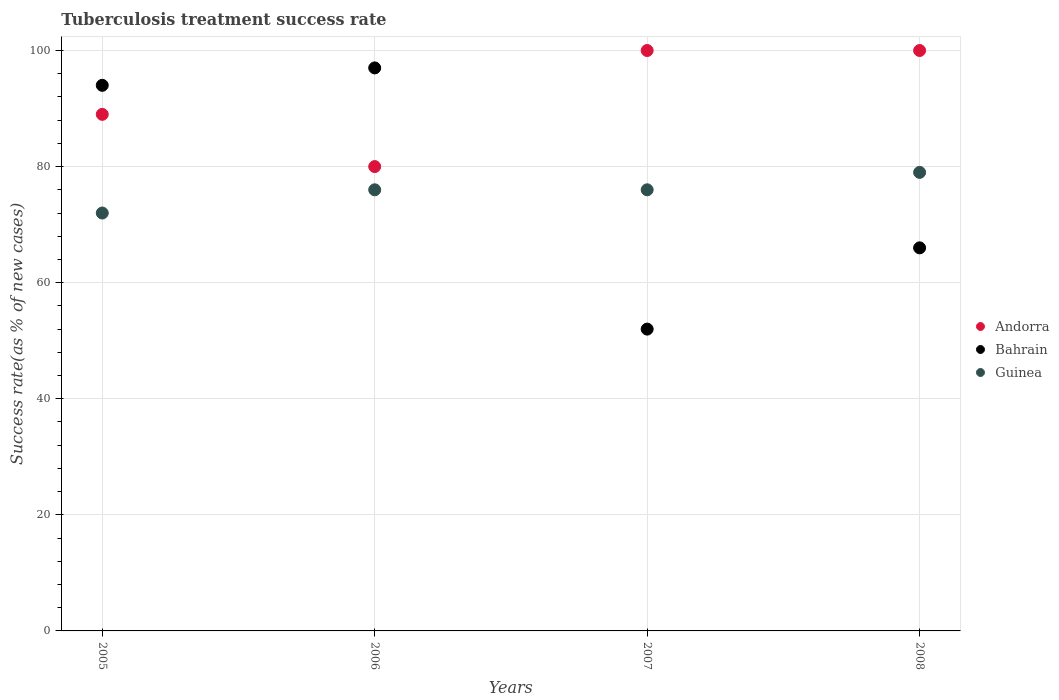How many different coloured dotlines are there?
Your response must be concise. 3. Across all years, what is the maximum tuberculosis treatment success rate in Guinea?
Provide a short and direct response. 79. In which year was the tuberculosis treatment success rate in Andorra minimum?
Make the answer very short. 2006. What is the total tuberculosis treatment success rate in Bahrain in the graph?
Give a very brief answer. 309. What is the difference between the tuberculosis treatment success rate in Andorra in 2006 and that in 2007?
Keep it short and to the point. -20. What is the difference between the tuberculosis treatment success rate in Andorra in 2007 and the tuberculosis treatment success rate in Bahrain in 2008?
Your answer should be very brief. 34. What is the average tuberculosis treatment success rate in Bahrain per year?
Offer a terse response. 77.25. Is the tuberculosis treatment success rate in Bahrain in 2005 less than that in 2008?
Your answer should be compact. No. What is the difference between the highest and the lowest tuberculosis treatment success rate in Guinea?
Make the answer very short. 7. In how many years, is the tuberculosis treatment success rate in Bahrain greater than the average tuberculosis treatment success rate in Bahrain taken over all years?
Your answer should be very brief. 2. Is the sum of the tuberculosis treatment success rate in Guinea in 2005 and 2007 greater than the maximum tuberculosis treatment success rate in Bahrain across all years?
Provide a short and direct response. Yes. Is it the case that in every year, the sum of the tuberculosis treatment success rate in Andorra and tuberculosis treatment success rate in Bahrain  is greater than the tuberculosis treatment success rate in Guinea?
Offer a terse response. Yes. Does the tuberculosis treatment success rate in Andorra monotonically increase over the years?
Make the answer very short. No. Is the tuberculosis treatment success rate in Andorra strictly greater than the tuberculosis treatment success rate in Bahrain over the years?
Your response must be concise. No. How many dotlines are there?
Ensure brevity in your answer.  3. What is the difference between two consecutive major ticks on the Y-axis?
Provide a short and direct response. 20. Does the graph contain any zero values?
Ensure brevity in your answer.  No. Where does the legend appear in the graph?
Provide a short and direct response. Center right. How many legend labels are there?
Give a very brief answer. 3. How are the legend labels stacked?
Your answer should be very brief. Vertical. What is the title of the graph?
Make the answer very short. Tuberculosis treatment success rate. What is the label or title of the Y-axis?
Your answer should be very brief. Success rate(as % of new cases). What is the Success rate(as % of new cases) of Andorra in 2005?
Your answer should be very brief. 89. What is the Success rate(as % of new cases) in Bahrain in 2005?
Provide a succinct answer. 94. What is the Success rate(as % of new cases) in Guinea in 2005?
Your answer should be compact. 72. What is the Success rate(as % of new cases) in Bahrain in 2006?
Your answer should be compact. 97. What is the Success rate(as % of new cases) of Guinea in 2006?
Your response must be concise. 76. What is the Success rate(as % of new cases) of Andorra in 2007?
Your response must be concise. 100. What is the Success rate(as % of new cases) in Bahrain in 2007?
Give a very brief answer. 52. What is the Success rate(as % of new cases) of Bahrain in 2008?
Offer a terse response. 66. What is the Success rate(as % of new cases) of Guinea in 2008?
Offer a very short reply. 79. Across all years, what is the maximum Success rate(as % of new cases) of Bahrain?
Your answer should be compact. 97. Across all years, what is the maximum Success rate(as % of new cases) of Guinea?
Your answer should be compact. 79. Across all years, what is the minimum Success rate(as % of new cases) in Andorra?
Ensure brevity in your answer.  80. What is the total Success rate(as % of new cases) of Andorra in the graph?
Provide a succinct answer. 369. What is the total Success rate(as % of new cases) of Bahrain in the graph?
Provide a short and direct response. 309. What is the total Success rate(as % of new cases) in Guinea in the graph?
Your answer should be compact. 303. What is the difference between the Success rate(as % of new cases) of Andorra in 2005 and that in 2006?
Make the answer very short. 9. What is the difference between the Success rate(as % of new cases) in Guinea in 2005 and that in 2006?
Your answer should be compact. -4. What is the difference between the Success rate(as % of new cases) in Bahrain in 2005 and that in 2007?
Keep it short and to the point. 42. What is the difference between the Success rate(as % of new cases) in Andorra in 2005 and that in 2008?
Provide a succinct answer. -11. What is the difference between the Success rate(as % of new cases) in Bahrain in 2005 and that in 2008?
Your answer should be compact. 28. What is the difference between the Success rate(as % of new cases) of Guinea in 2006 and that in 2007?
Give a very brief answer. 0. What is the difference between the Success rate(as % of new cases) of Bahrain in 2007 and that in 2008?
Offer a terse response. -14. What is the difference between the Success rate(as % of new cases) of Guinea in 2007 and that in 2008?
Keep it short and to the point. -3. What is the difference between the Success rate(as % of new cases) of Andorra in 2005 and the Success rate(as % of new cases) of Bahrain in 2007?
Give a very brief answer. 37. What is the difference between the Success rate(as % of new cases) in Andorra in 2005 and the Success rate(as % of new cases) in Guinea in 2007?
Provide a short and direct response. 13. What is the difference between the Success rate(as % of new cases) in Andorra in 2005 and the Success rate(as % of new cases) in Bahrain in 2008?
Ensure brevity in your answer.  23. What is the difference between the Success rate(as % of new cases) of Andorra in 2006 and the Success rate(as % of new cases) of Guinea in 2007?
Provide a succinct answer. 4. What is the difference between the Success rate(as % of new cases) of Bahrain in 2006 and the Success rate(as % of new cases) of Guinea in 2007?
Offer a terse response. 21. What is the difference between the Success rate(as % of new cases) of Andorra in 2006 and the Success rate(as % of new cases) of Bahrain in 2008?
Offer a terse response. 14. What is the difference between the Success rate(as % of new cases) in Bahrain in 2006 and the Success rate(as % of new cases) in Guinea in 2008?
Offer a very short reply. 18. What is the difference between the Success rate(as % of new cases) of Andorra in 2007 and the Success rate(as % of new cases) of Bahrain in 2008?
Make the answer very short. 34. What is the difference between the Success rate(as % of new cases) of Andorra in 2007 and the Success rate(as % of new cases) of Guinea in 2008?
Keep it short and to the point. 21. What is the difference between the Success rate(as % of new cases) of Bahrain in 2007 and the Success rate(as % of new cases) of Guinea in 2008?
Provide a short and direct response. -27. What is the average Success rate(as % of new cases) of Andorra per year?
Your answer should be very brief. 92.25. What is the average Success rate(as % of new cases) in Bahrain per year?
Your answer should be compact. 77.25. What is the average Success rate(as % of new cases) in Guinea per year?
Offer a very short reply. 75.75. In the year 2005, what is the difference between the Success rate(as % of new cases) of Andorra and Success rate(as % of new cases) of Bahrain?
Offer a terse response. -5. In the year 2005, what is the difference between the Success rate(as % of new cases) in Andorra and Success rate(as % of new cases) in Guinea?
Your answer should be compact. 17. In the year 2006, what is the difference between the Success rate(as % of new cases) of Andorra and Success rate(as % of new cases) of Guinea?
Give a very brief answer. 4. In the year 2006, what is the difference between the Success rate(as % of new cases) of Bahrain and Success rate(as % of new cases) of Guinea?
Ensure brevity in your answer.  21. In the year 2007, what is the difference between the Success rate(as % of new cases) in Andorra and Success rate(as % of new cases) in Bahrain?
Keep it short and to the point. 48. In the year 2007, what is the difference between the Success rate(as % of new cases) of Andorra and Success rate(as % of new cases) of Guinea?
Offer a terse response. 24. In the year 2008, what is the difference between the Success rate(as % of new cases) in Andorra and Success rate(as % of new cases) in Guinea?
Your answer should be very brief. 21. In the year 2008, what is the difference between the Success rate(as % of new cases) of Bahrain and Success rate(as % of new cases) of Guinea?
Offer a very short reply. -13. What is the ratio of the Success rate(as % of new cases) of Andorra in 2005 to that in 2006?
Give a very brief answer. 1.11. What is the ratio of the Success rate(as % of new cases) of Bahrain in 2005 to that in 2006?
Your answer should be compact. 0.97. What is the ratio of the Success rate(as % of new cases) of Guinea in 2005 to that in 2006?
Your answer should be compact. 0.95. What is the ratio of the Success rate(as % of new cases) in Andorra in 2005 to that in 2007?
Your answer should be compact. 0.89. What is the ratio of the Success rate(as % of new cases) of Bahrain in 2005 to that in 2007?
Offer a terse response. 1.81. What is the ratio of the Success rate(as % of new cases) in Andorra in 2005 to that in 2008?
Offer a terse response. 0.89. What is the ratio of the Success rate(as % of new cases) in Bahrain in 2005 to that in 2008?
Provide a short and direct response. 1.42. What is the ratio of the Success rate(as % of new cases) in Guinea in 2005 to that in 2008?
Offer a terse response. 0.91. What is the ratio of the Success rate(as % of new cases) in Andorra in 2006 to that in 2007?
Offer a very short reply. 0.8. What is the ratio of the Success rate(as % of new cases) in Bahrain in 2006 to that in 2007?
Make the answer very short. 1.87. What is the ratio of the Success rate(as % of new cases) of Guinea in 2006 to that in 2007?
Offer a very short reply. 1. What is the ratio of the Success rate(as % of new cases) of Andorra in 2006 to that in 2008?
Offer a terse response. 0.8. What is the ratio of the Success rate(as % of new cases) of Bahrain in 2006 to that in 2008?
Make the answer very short. 1.47. What is the ratio of the Success rate(as % of new cases) of Andorra in 2007 to that in 2008?
Provide a short and direct response. 1. What is the ratio of the Success rate(as % of new cases) of Bahrain in 2007 to that in 2008?
Give a very brief answer. 0.79. What is the ratio of the Success rate(as % of new cases) of Guinea in 2007 to that in 2008?
Your answer should be very brief. 0.96. What is the difference between the highest and the second highest Success rate(as % of new cases) in Andorra?
Provide a succinct answer. 0. What is the difference between the highest and the lowest Success rate(as % of new cases) in Bahrain?
Your answer should be compact. 45. What is the difference between the highest and the lowest Success rate(as % of new cases) in Guinea?
Ensure brevity in your answer.  7. 